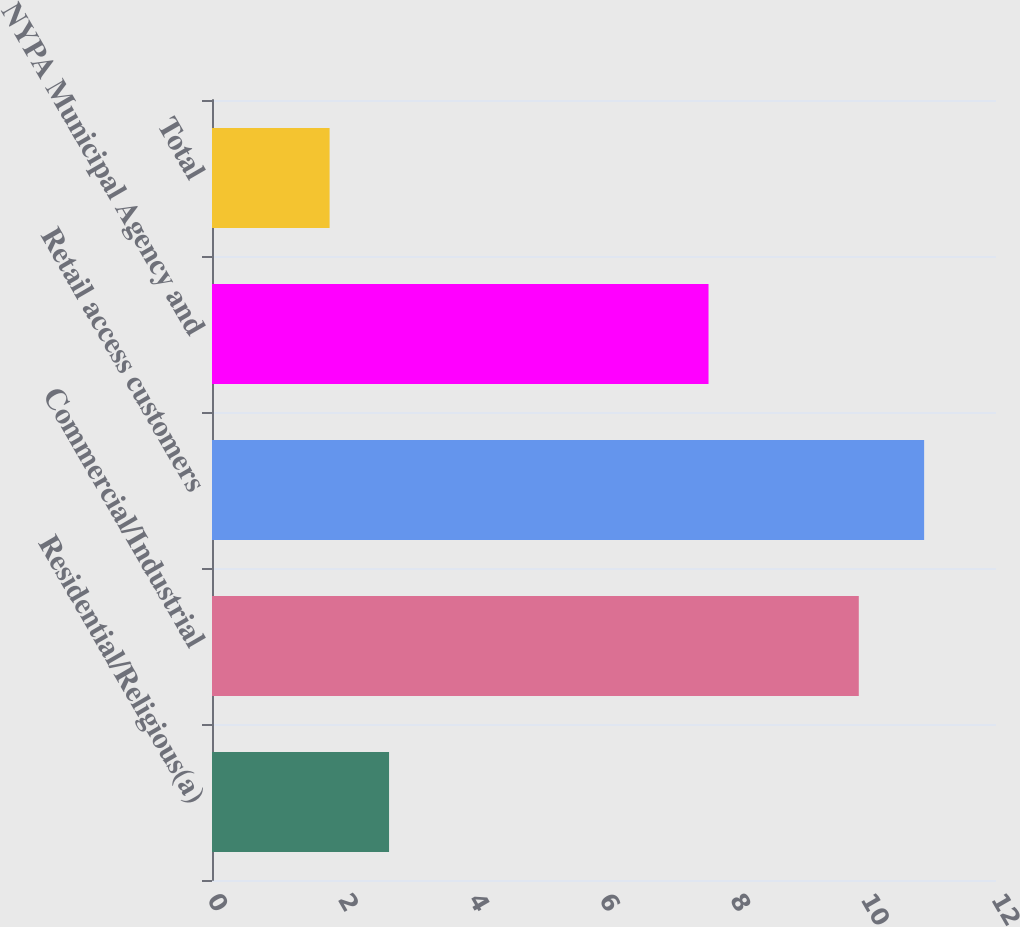Convert chart. <chart><loc_0><loc_0><loc_500><loc_500><bar_chart><fcel>Residential/Religious(a)<fcel>Commercial/Industrial<fcel>Retail access customers<fcel>NYPA Municipal Agency and<fcel>Total<nl><fcel>2.71<fcel>9.9<fcel>10.9<fcel>7.6<fcel>1.8<nl></chart> 